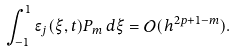Convert formula to latex. <formula><loc_0><loc_0><loc_500><loc_500>\int _ { - 1 } ^ { 1 } \epsilon _ { j } ( \xi , t ) P _ { m } \, d \xi = \mathcal { O } ( h ^ { 2 p + 1 - m } ) .</formula> 